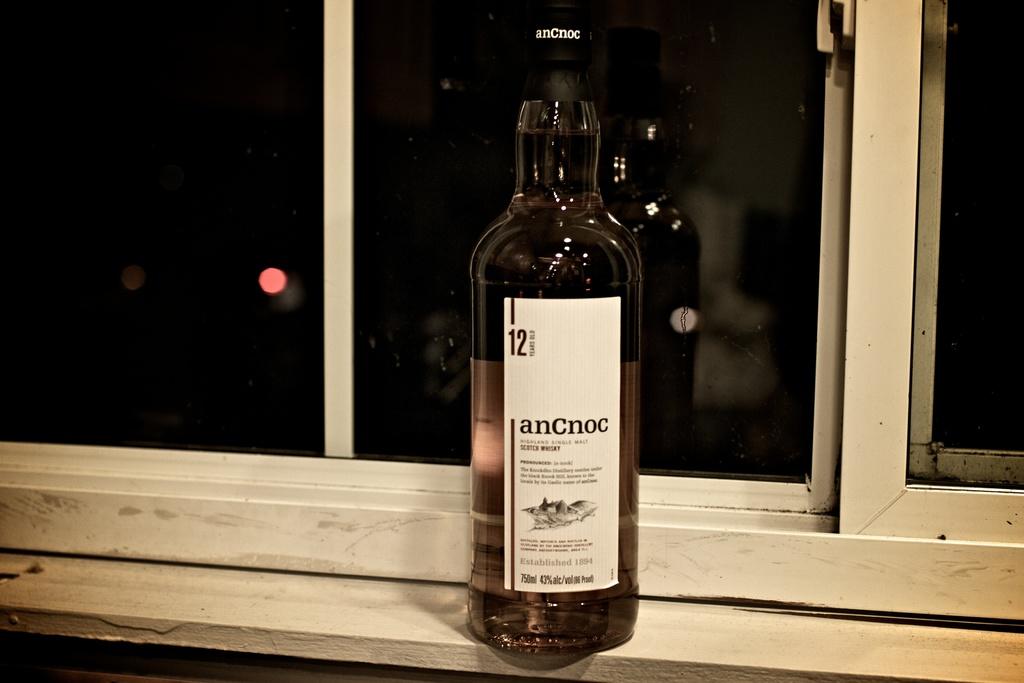What is the name of this alcohol?
Make the answer very short. Ancnoc. 